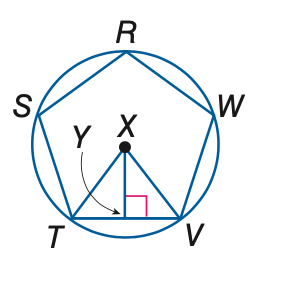Answer the mathemtical geometry problem and directly provide the correct option letter.
Question: In the figure, a regular polygon is inscribed in a circle. Find the measure of a central angle.
Choices: A: 18 B: 36 C: 72 D: 144 C 